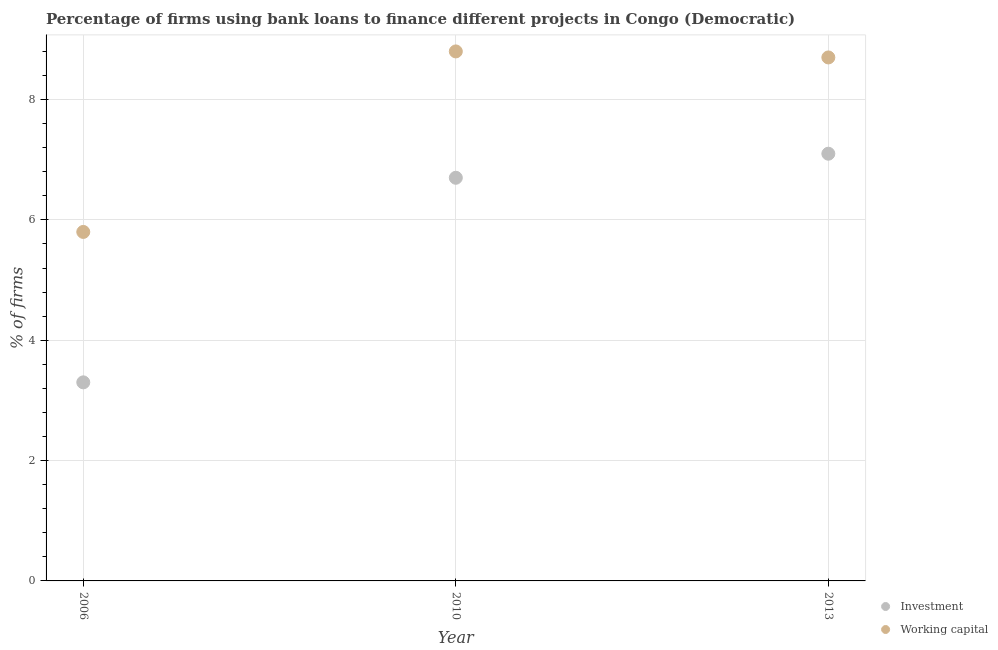How many different coloured dotlines are there?
Your answer should be compact. 2. Across all years, what is the minimum percentage of firms using banks to finance investment?
Provide a succinct answer. 3.3. In which year was the percentage of firms using banks to finance investment maximum?
Ensure brevity in your answer.  2013. What is the total percentage of firms using banks to finance working capital in the graph?
Give a very brief answer. 23.3. What is the difference between the percentage of firms using banks to finance working capital in 2006 and that in 2010?
Ensure brevity in your answer.  -3. What is the difference between the percentage of firms using banks to finance investment in 2010 and the percentage of firms using banks to finance working capital in 2013?
Keep it short and to the point. -2. What is the average percentage of firms using banks to finance investment per year?
Keep it short and to the point. 5.7. In how many years, is the percentage of firms using banks to finance working capital greater than 0.4 %?
Make the answer very short. 3. What is the ratio of the percentage of firms using banks to finance working capital in 2006 to that in 2010?
Your answer should be very brief. 0.66. Is the difference between the percentage of firms using banks to finance investment in 2010 and 2013 greater than the difference between the percentage of firms using banks to finance working capital in 2010 and 2013?
Offer a terse response. No. What is the difference between the highest and the second highest percentage of firms using banks to finance working capital?
Ensure brevity in your answer.  0.1. What is the difference between the highest and the lowest percentage of firms using banks to finance working capital?
Keep it short and to the point. 3. Is the sum of the percentage of firms using banks to finance investment in 2006 and 2013 greater than the maximum percentage of firms using banks to finance working capital across all years?
Make the answer very short. Yes. How many dotlines are there?
Offer a very short reply. 2. What is the difference between two consecutive major ticks on the Y-axis?
Ensure brevity in your answer.  2. Does the graph contain any zero values?
Your answer should be very brief. No. Does the graph contain grids?
Your answer should be very brief. Yes. Where does the legend appear in the graph?
Provide a succinct answer. Bottom right. What is the title of the graph?
Your response must be concise. Percentage of firms using bank loans to finance different projects in Congo (Democratic). What is the label or title of the X-axis?
Give a very brief answer. Year. What is the label or title of the Y-axis?
Keep it short and to the point. % of firms. What is the % of firms in Investment in 2006?
Make the answer very short. 3.3. What is the % of firms in Investment in 2010?
Your answer should be very brief. 6.7. What is the % of firms of Working capital in 2013?
Offer a terse response. 8.7. Across all years, what is the maximum % of firms in Investment?
Ensure brevity in your answer.  7.1. Across all years, what is the minimum % of firms in Working capital?
Provide a succinct answer. 5.8. What is the total % of firms of Working capital in the graph?
Keep it short and to the point. 23.3. What is the difference between the % of firms in Investment in 2006 and that in 2010?
Make the answer very short. -3.4. What is the difference between the % of firms of Working capital in 2006 and that in 2010?
Offer a very short reply. -3. What is the difference between the % of firms in Working capital in 2006 and that in 2013?
Provide a short and direct response. -2.9. What is the difference between the % of firms of Investment in 2010 and that in 2013?
Keep it short and to the point. -0.4. What is the difference between the % of firms in Investment in 2006 and the % of firms in Working capital in 2010?
Make the answer very short. -5.5. What is the average % of firms in Working capital per year?
Offer a terse response. 7.77. In the year 2010, what is the difference between the % of firms in Investment and % of firms in Working capital?
Keep it short and to the point. -2.1. What is the ratio of the % of firms of Investment in 2006 to that in 2010?
Your answer should be compact. 0.49. What is the ratio of the % of firms in Working capital in 2006 to that in 2010?
Offer a very short reply. 0.66. What is the ratio of the % of firms of Investment in 2006 to that in 2013?
Keep it short and to the point. 0.46. What is the ratio of the % of firms of Investment in 2010 to that in 2013?
Give a very brief answer. 0.94. What is the ratio of the % of firms in Working capital in 2010 to that in 2013?
Provide a short and direct response. 1.01. 